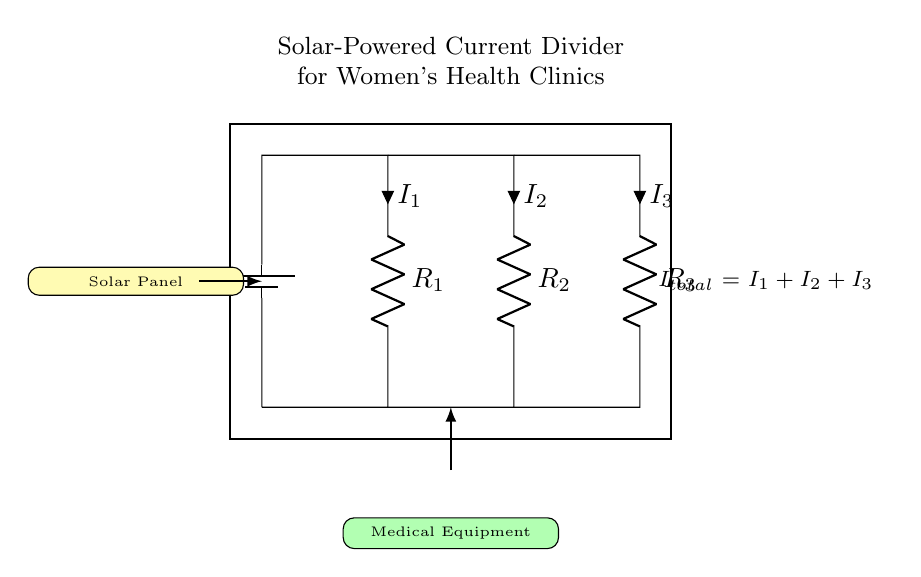What is the power source for this circuit? The power source for this circuit is a solar panel, indicated by the notation on the diagram. This is located at the top left of the circuit.
Answer: solar panel What are the resistors in this circuit? The circuit has three resistors labeled R1, R2, and R3. These are connected in parallel configuration, indicated by their arrangement and the parallel connections leading to them.
Answer: R1, R2, R3 What is the total current in the circuit? The total current in the circuit is expressed as I total, which is equal to the sum of the individual currents I1, I2, and I3 flowing through the resistors. This is stated directly in the diagram.
Answer: I total = I1 + I2 + I3 If R2 is twice the value of R1, how does it affect the currents? Since R2 is twice the value of R1, the current through R2 will be half of that through R1 when connected in parallel. This is because current distribution in a parallel circuit is inversely proportional to the resistances.
Answer: I2 = I1 / 2 Which component is responsible for supplying power? The component responsible for supplying power in this circuit is the solar panel. It converts sunlight into electrical energy that is distributed to the resistors.
Answer: solar panel What happens to the current when R3 is removed from the circuit? When R3 is removed, the total resistance decreases, which will increase the total current flowing in the circuit according to Ohm's law, since the remaining resistors R1 and R2 will still allow current to flow.
Answer: Increases total current 